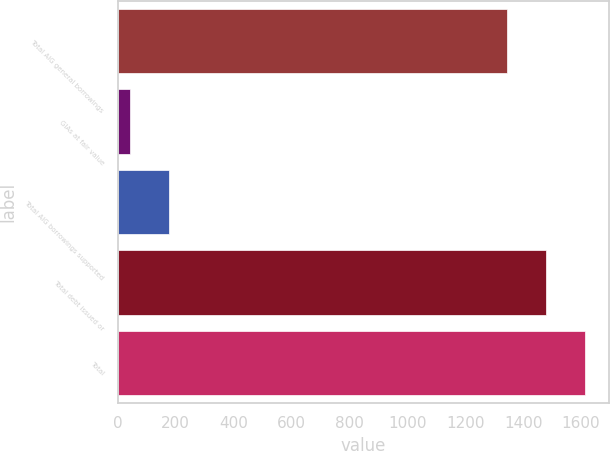<chart> <loc_0><loc_0><loc_500><loc_500><bar_chart><fcel>Total AIG general borrowings<fcel>GIAs at fair value<fcel>Total AIG borrowings supported<fcel>Total debt issued or<fcel>Total<nl><fcel>1345<fcel>41<fcel>175.5<fcel>1479.5<fcel>1614<nl></chart> 